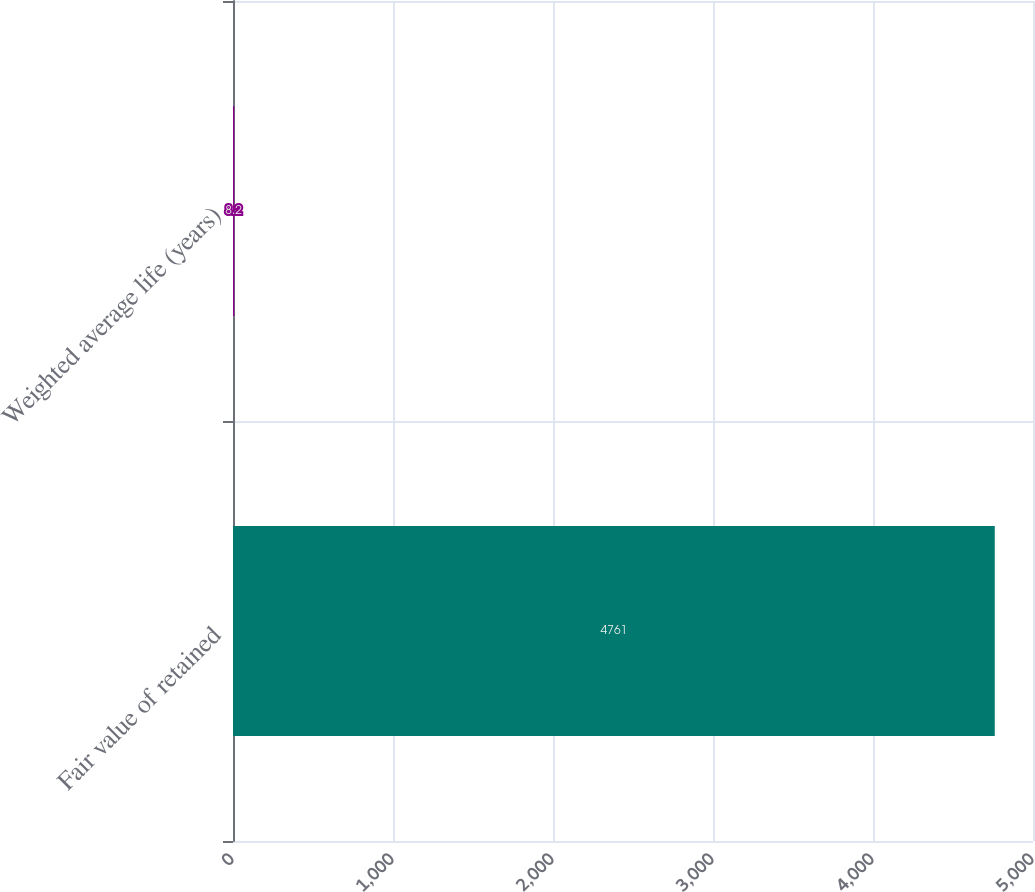Convert chart. <chart><loc_0><loc_0><loc_500><loc_500><bar_chart><fcel>Fair value of retained<fcel>Weighted average life (years)<nl><fcel>4761<fcel>8.2<nl></chart> 